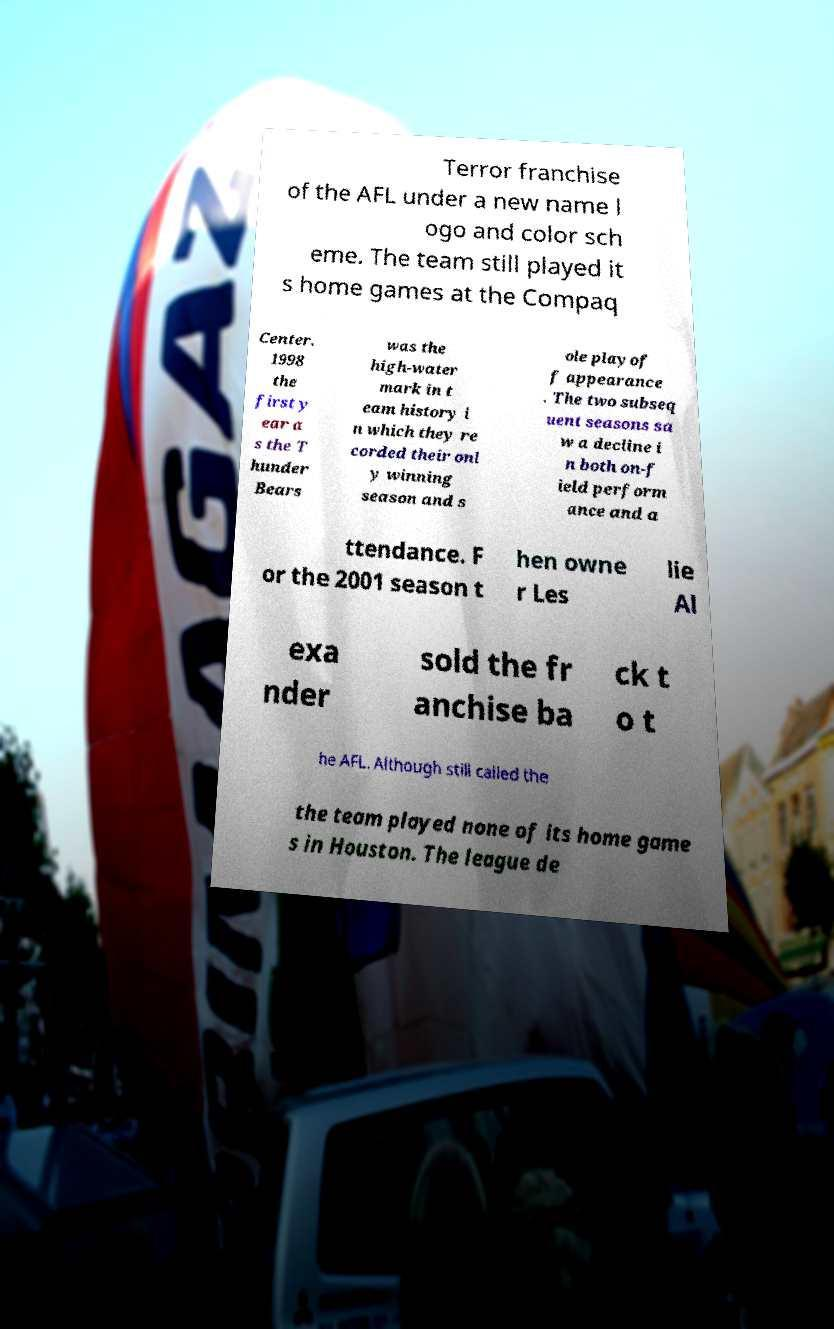Could you extract and type out the text from this image? Terror franchise of the AFL under a new name l ogo and color sch eme. The team still played it s home games at the Compaq Center. 1998 the first y ear a s the T hunder Bears was the high-water mark in t eam history i n which they re corded their onl y winning season and s ole playof f appearance . The two subseq uent seasons sa w a decline i n both on-f ield perform ance and a ttendance. F or the 2001 season t hen owne r Les lie Al exa nder sold the fr anchise ba ck t o t he AFL. Although still called the the team played none of its home game s in Houston. The league de 